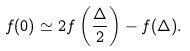<formula> <loc_0><loc_0><loc_500><loc_500>f ( 0 ) \simeq 2 f \left ( \frac { \Delta } { 2 } \right ) - f ( \Delta ) .</formula> 